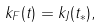<formula> <loc_0><loc_0><loc_500><loc_500>k _ { F } ( t ) = k _ { J } ( t _ { * } ) ,</formula> 